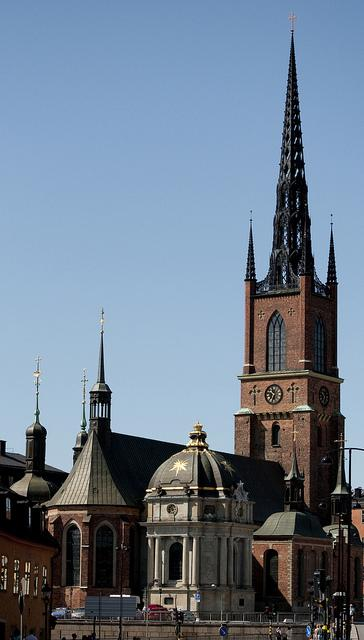What design is next to the clock on the largest building? cross 